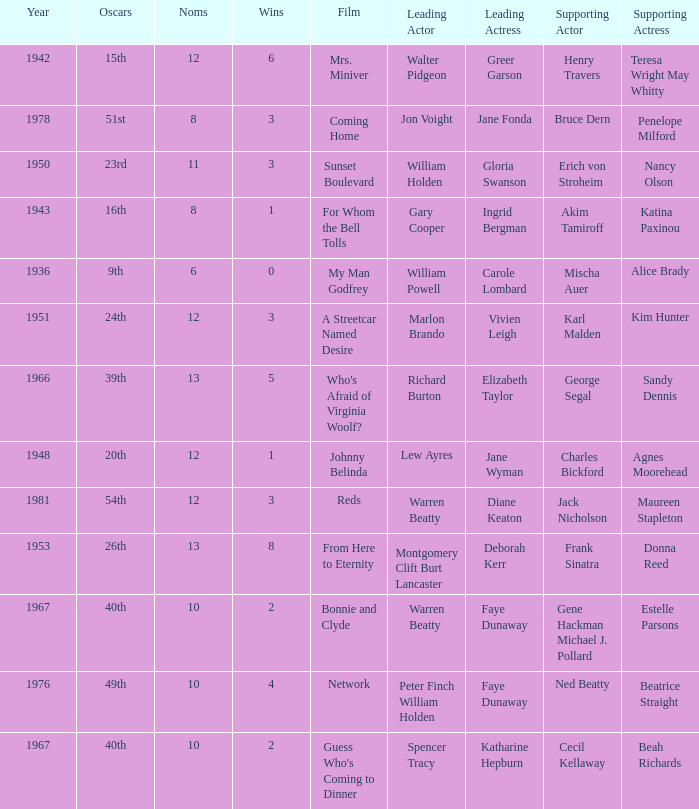Who was the supporting actress in "For Whom the Bell Tolls"? Katina Paxinou. 